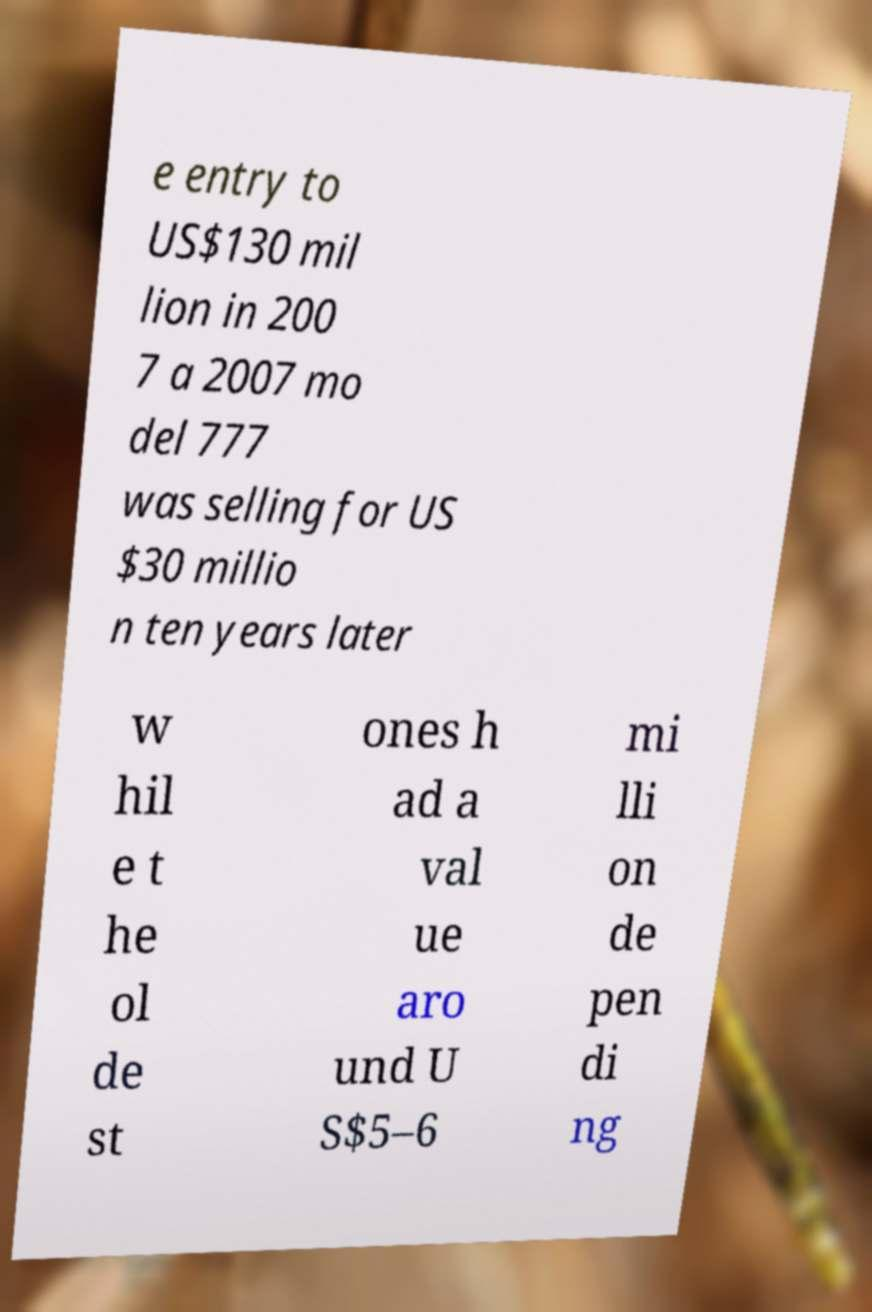Can you read and provide the text displayed in the image?This photo seems to have some interesting text. Can you extract and type it out for me? e entry to US$130 mil lion in 200 7 a 2007 mo del 777 was selling for US $30 millio n ten years later w hil e t he ol de st ones h ad a val ue aro und U S$5–6 mi lli on de pen di ng 